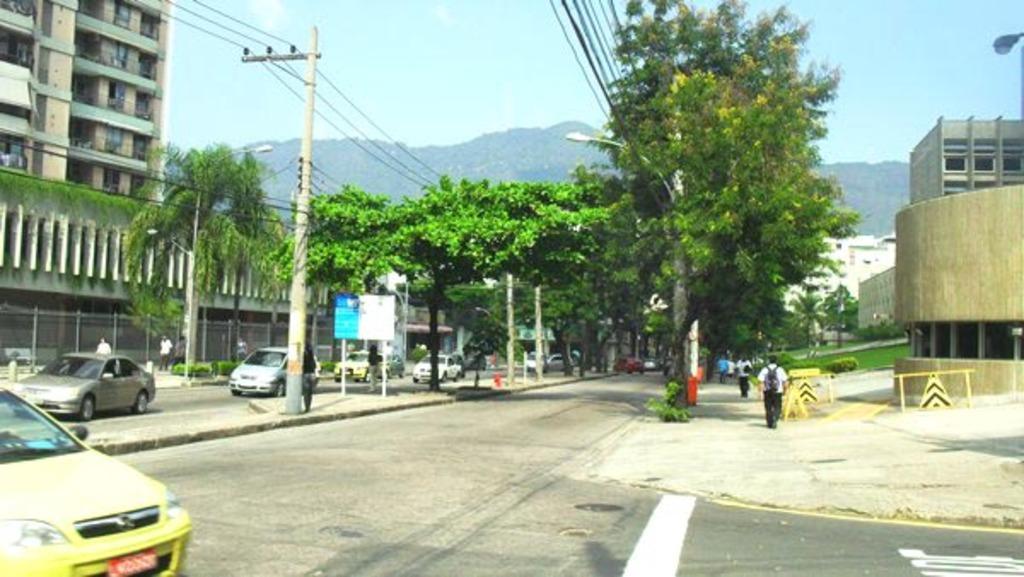Can you describe this image briefly? In this image, there are trees, plants, buildings, street lights, electric poles with current wires, a board with poles, people and there are vehicles on the road. On the right side of the image, I can see road barriers. In the background there are hills and the sky. 